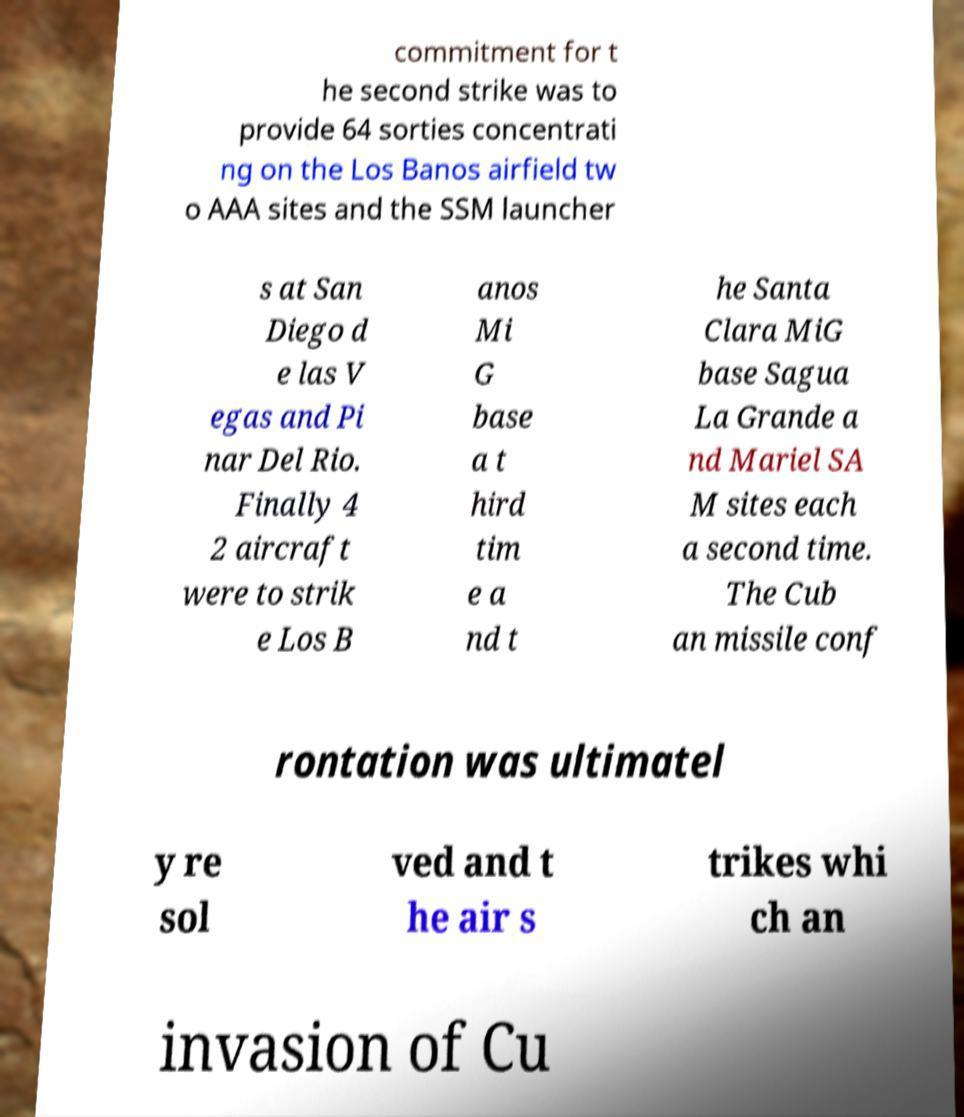For documentation purposes, I need the text within this image transcribed. Could you provide that? commitment for t he second strike was to provide 64 sorties concentrati ng on the Los Banos airfield tw o AAA sites and the SSM launcher s at San Diego d e las V egas and Pi nar Del Rio. Finally 4 2 aircraft were to strik e Los B anos Mi G base a t hird tim e a nd t he Santa Clara MiG base Sagua La Grande a nd Mariel SA M sites each a second time. The Cub an missile conf rontation was ultimatel y re sol ved and t he air s trikes whi ch an invasion of Cu 